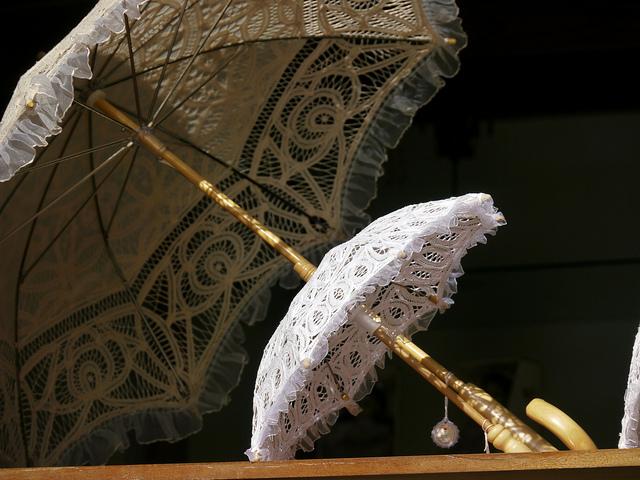Would this umbrella keep you dry?
Write a very short answer. No. Is this two umbrella in one?
Quick response, please. Yes. Is the umbrella open?
Concise answer only. Yes. 